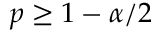Convert formula to latex. <formula><loc_0><loc_0><loc_500><loc_500>p \geq 1 - \alpha / 2</formula> 